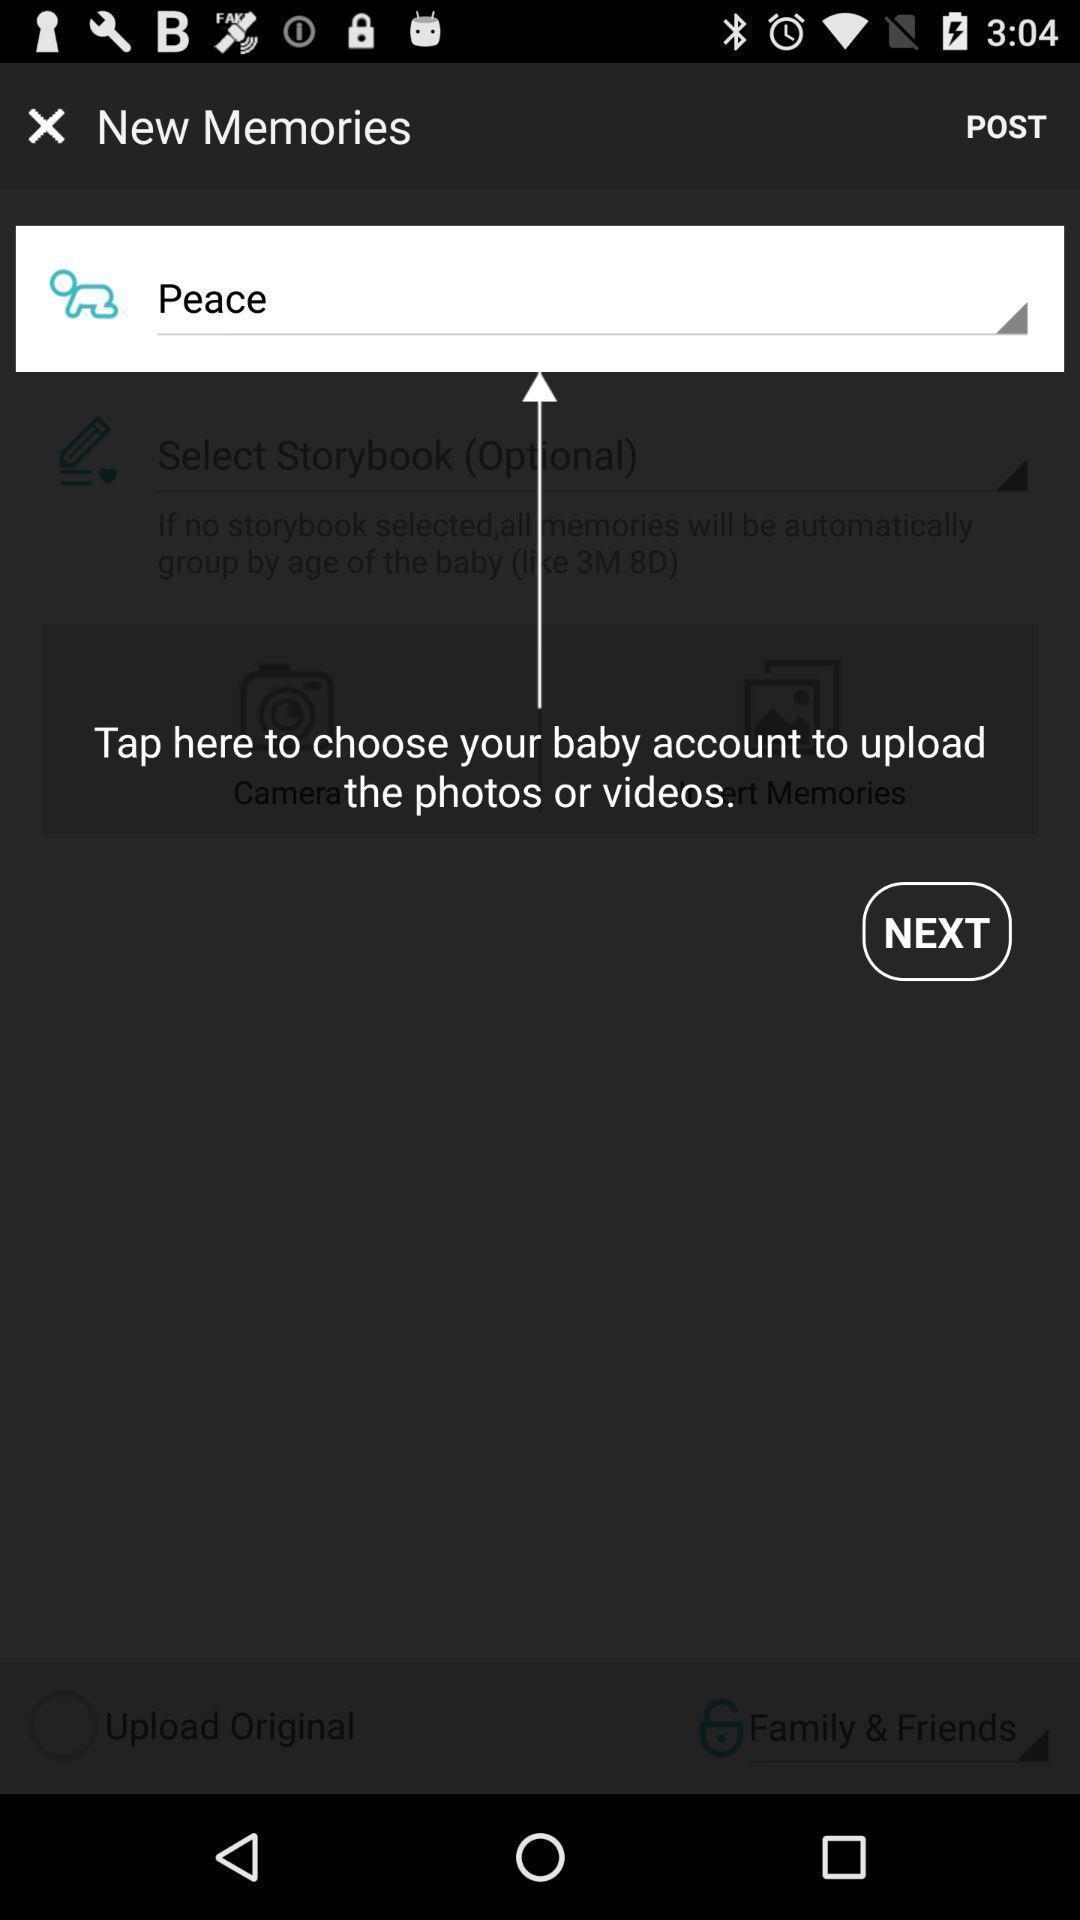Describe the content in this image. Push up notification displayed instructions to upload photo and videos. 